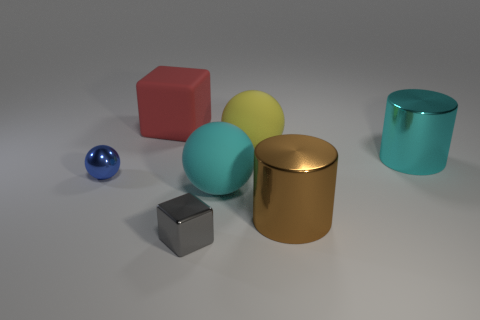Add 1 shiny things. How many objects exist? 8 Subtract all blocks. How many objects are left? 5 Subtract all yellow things. Subtract all tiny blue spheres. How many objects are left? 5 Add 3 large red cubes. How many large red cubes are left? 4 Add 3 small red cylinders. How many small red cylinders exist? 3 Subtract 1 yellow spheres. How many objects are left? 6 